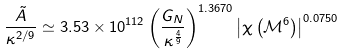<formula> <loc_0><loc_0><loc_500><loc_500>\frac { \tilde { A } } { \kappa ^ { 2 / 9 } } \simeq 3 . 5 3 \times 1 0 ^ { 1 1 2 } \left ( \frac { G _ { N } } { \kappa ^ { \frac { 4 } { 9 } } } \right ) ^ { 1 . 3 6 7 0 } \left | \chi \left ( \mathcal { M } ^ { 6 } \right ) \right | ^ { 0 . 0 7 5 0 }</formula> 